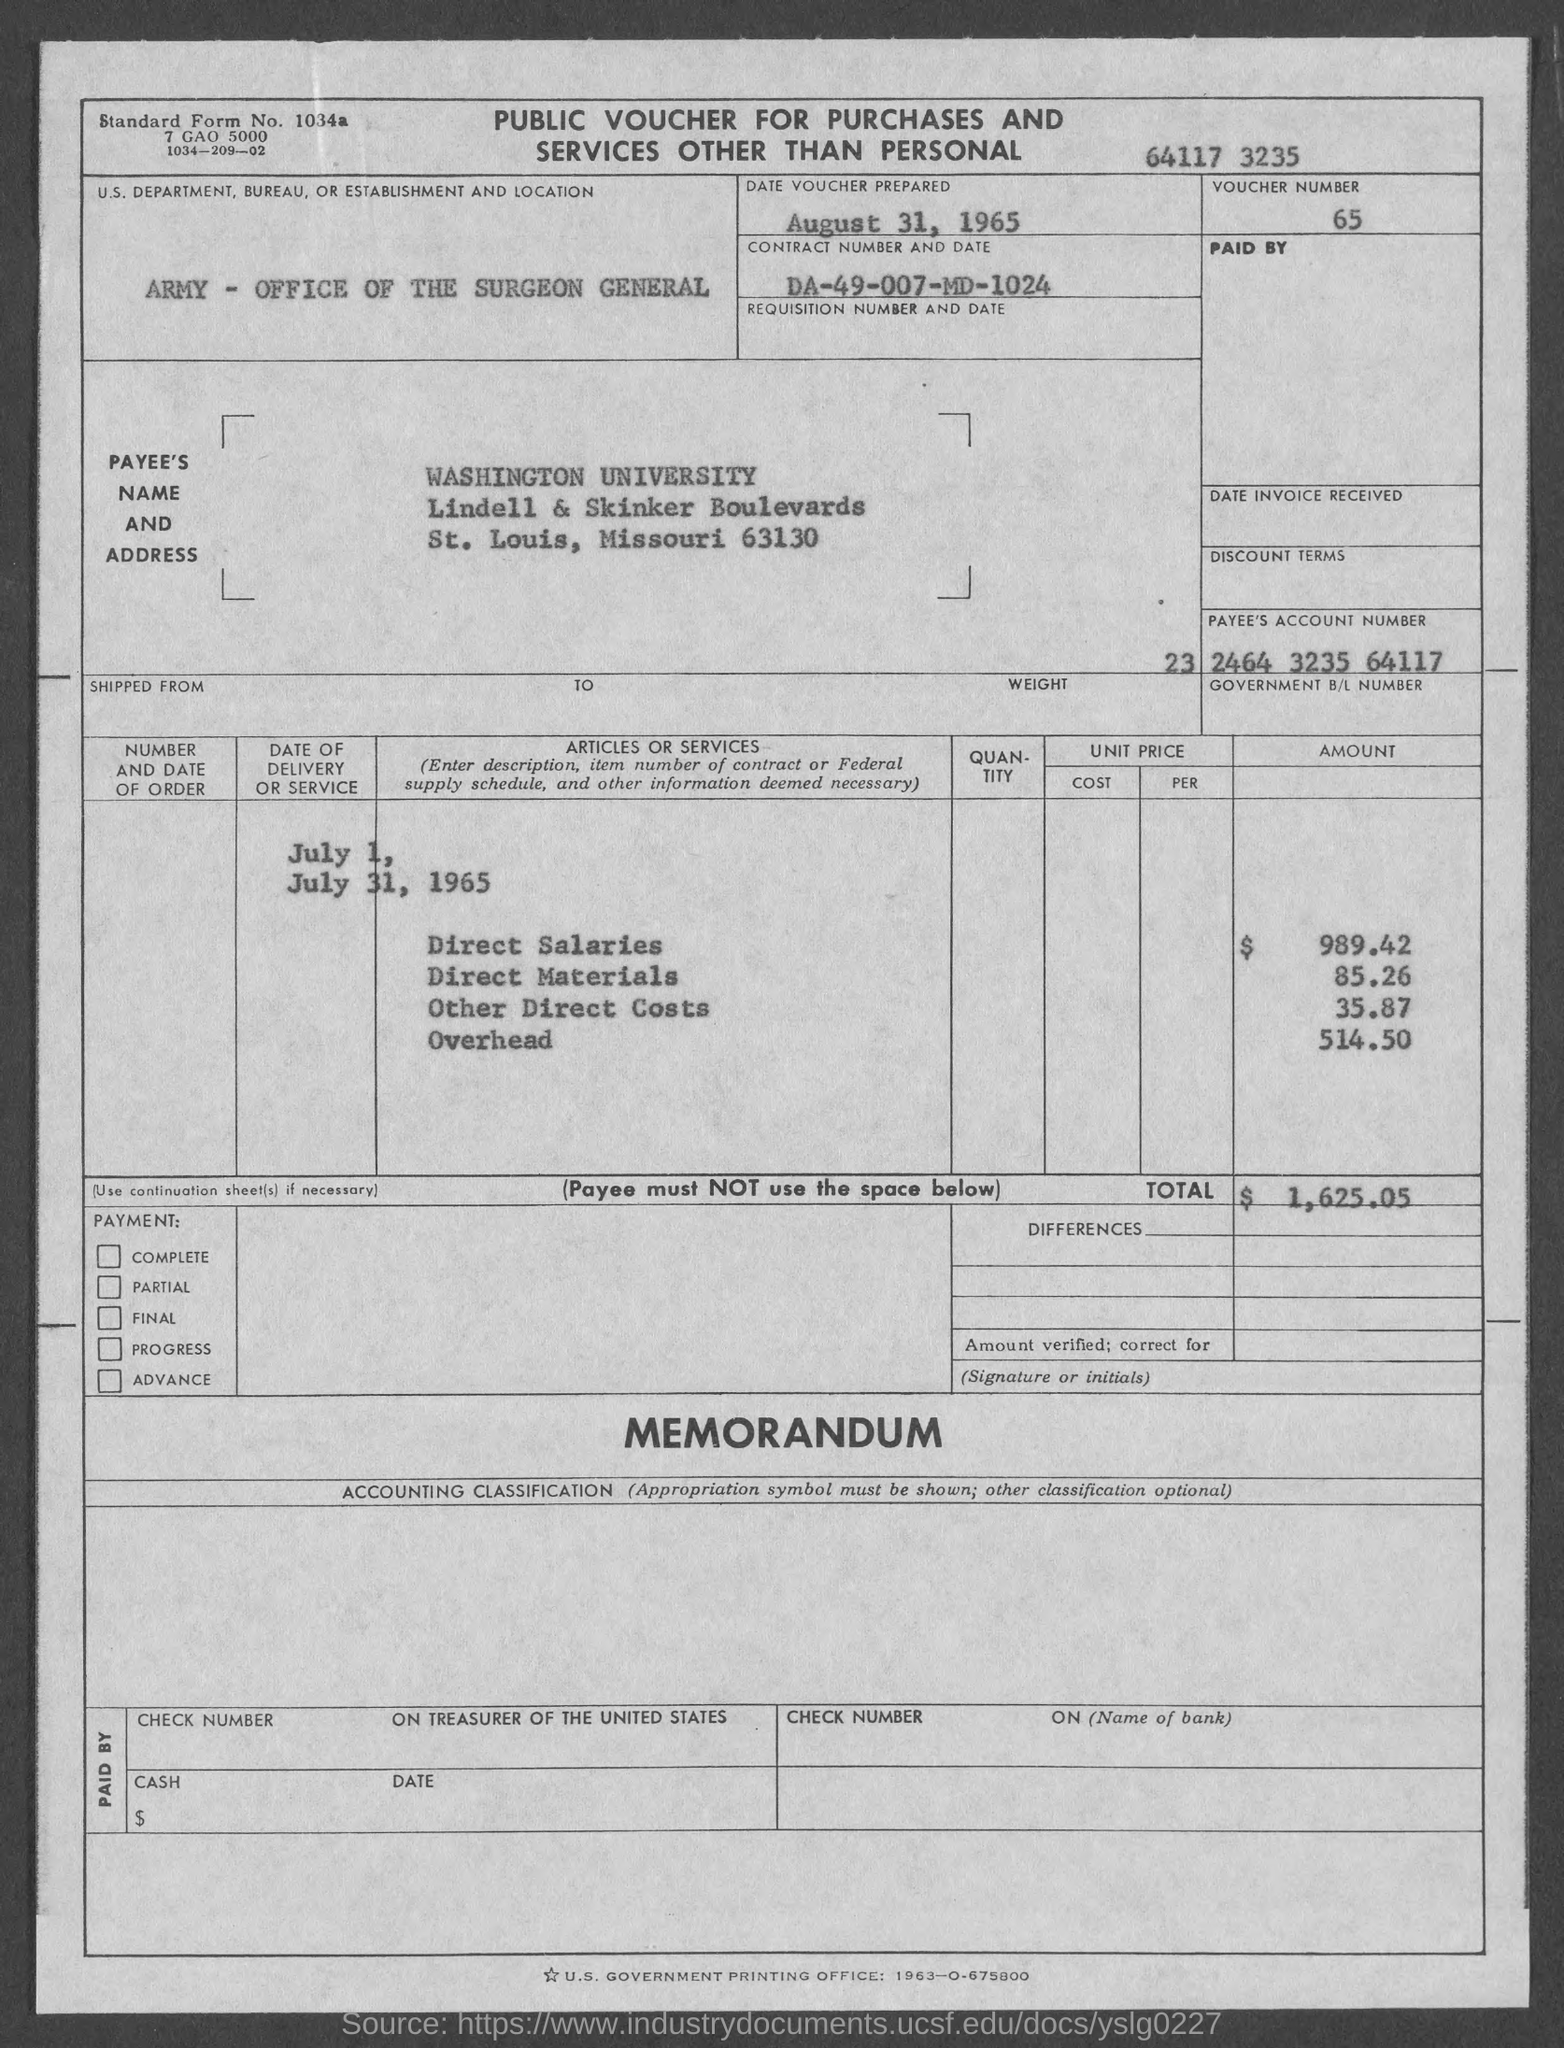What is the voucher number ?
Provide a short and direct response. 65. On what date is voucher prepared ?
Offer a very short reply. August 31, 1965. In which state is washington university at?
Make the answer very short. MISSOURI. What is the payee's account number ?
Your answer should be very brief. 23 2464 3235 64117. What is the total?
Offer a very short reply. $ 1,625 05. What is the amount of direct salaries ?
Provide a short and direct response. $989.42. What is the amount of direct materials?
Provide a short and direct response. 85 26. What is the amount of other direct costs?
Offer a terse response. 35.87. What is the amount of overhead ?
Offer a terse response. 514 50. 